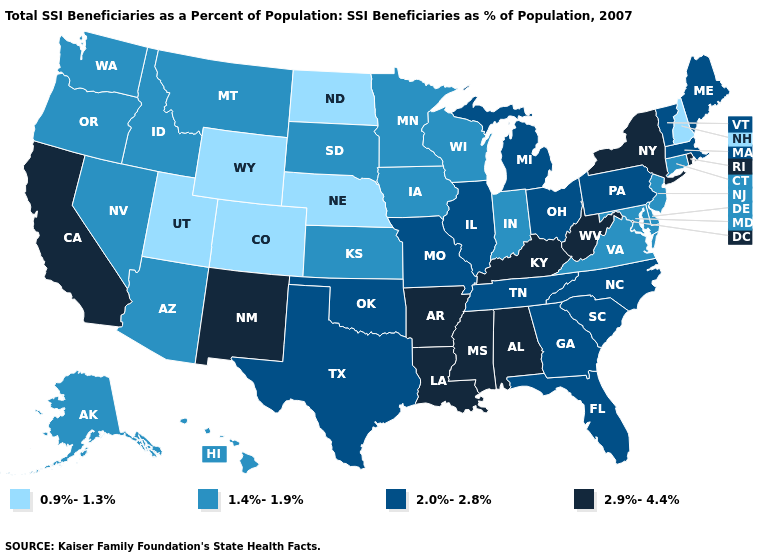What is the value of Oklahoma?
Keep it brief. 2.0%-2.8%. Name the states that have a value in the range 2.0%-2.8%?
Write a very short answer. Florida, Georgia, Illinois, Maine, Massachusetts, Michigan, Missouri, North Carolina, Ohio, Oklahoma, Pennsylvania, South Carolina, Tennessee, Texas, Vermont. What is the value of Georgia?
Write a very short answer. 2.0%-2.8%. Does Montana have a higher value than New Hampshire?
Quick response, please. Yes. How many symbols are there in the legend?
Be succinct. 4. Which states have the lowest value in the South?
Concise answer only. Delaware, Maryland, Virginia. Does Indiana have the lowest value in the USA?
Write a very short answer. No. Among the states that border Iowa , does Nebraska have the lowest value?
Give a very brief answer. Yes. What is the lowest value in the USA?
Write a very short answer. 0.9%-1.3%. Does Iowa have the highest value in the MidWest?
Quick response, please. No. Among the states that border Illinois , which have the highest value?
Give a very brief answer. Kentucky. Does the map have missing data?
Give a very brief answer. No. What is the value of Minnesota?
Keep it brief. 1.4%-1.9%. Name the states that have a value in the range 2.9%-4.4%?
Write a very short answer. Alabama, Arkansas, California, Kentucky, Louisiana, Mississippi, New Mexico, New York, Rhode Island, West Virginia. Name the states that have a value in the range 1.4%-1.9%?
Quick response, please. Alaska, Arizona, Connecticut, Delaware, Hawaii, Idaho, Indiana, Iowa, Kansas, Maryland, Minnesota, Montana, Nevada, New Jersey, Oregon, South Dakota, Virginia, Washington, Wisconsin. 